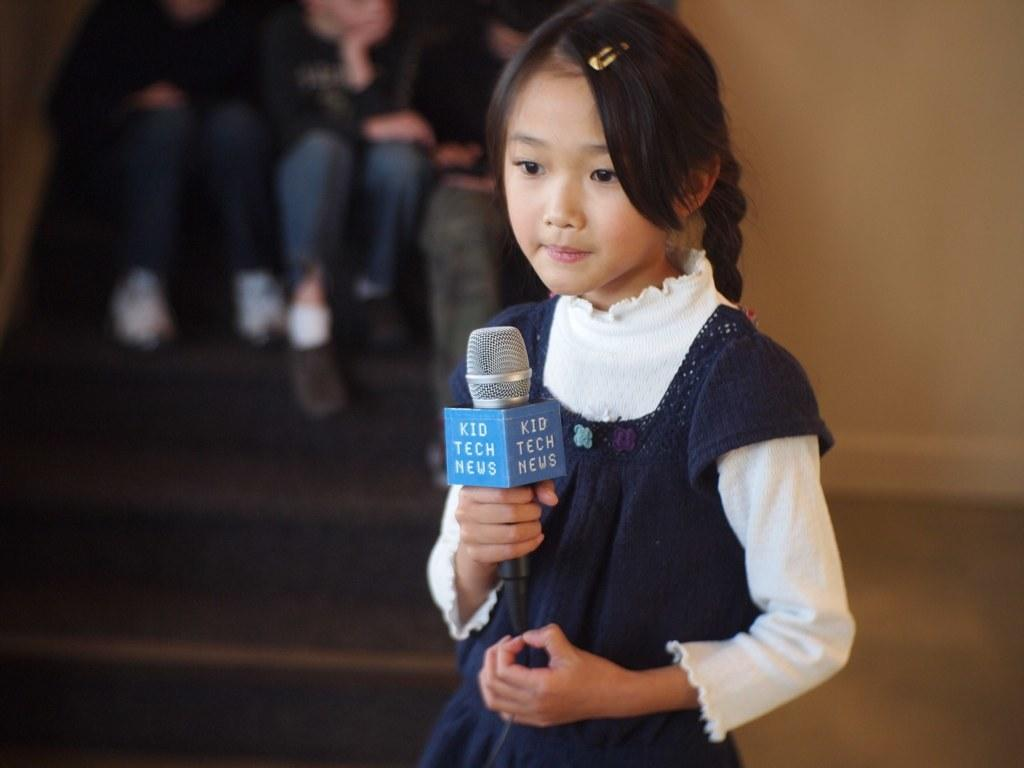What is the main subject of the image? The main subject of the image is a kid. What is the kid holding in the image? The kid is holding a microphone. What can be seen behind the kid in the image? There is a wall visible behind the kid. What are the other people in the image doing? There are persons sitting on the steps in the image. What type of team is the kid leading in the image? There is no team present in the image, and the kid is not shown leading any group. 